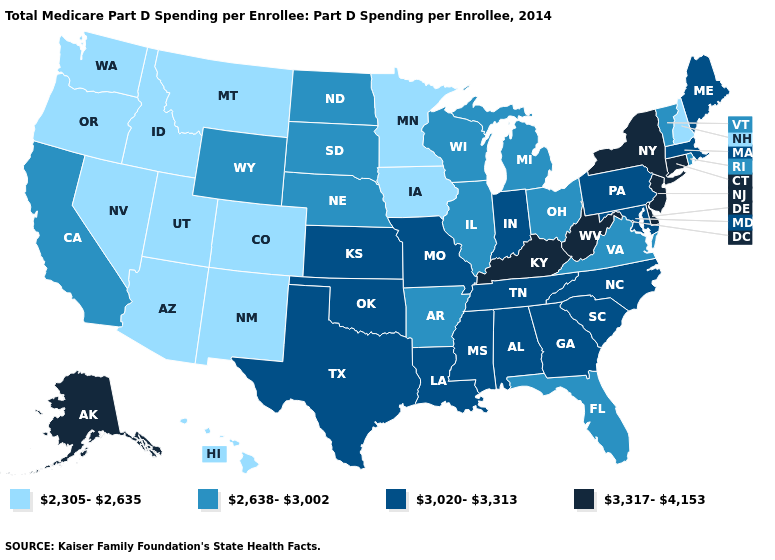What is the lowest value in the South?
Be succinct. 2,638-3,002. Name the states that have a value in the range 3,317-4,153?
Be succinct. Alaska, Connecticut, Delaware, Kentucky, New Jersey, New York, West Virginia. Does Utah have the lowest value in the West?
Give a very brief answer. Yes. Name the states that have a value in the range 2,305-2,635?
Quick response, please. Arizona, Colorado, Hawaii, Idaho, Iowa, Minnesota, Montana, Nevada, New Hampshire, New Mexico, Oregon, Utah, Washington. What is the highest value in the USA?
Short answer required. 3,317-4,153. Name the states that have a value in the range 3,317-4,153?
Be succinct. Alaska, Connecticut, Delaware, Kentucky, New Jersey, New York, West Virginia. What is the value of West Virginia?
Short answer required. 3,317-4,153. Among the states that border Nebraska , which have the highest value?
Answer briefly. Kansas, Missouri. Name the states that have a value in the range 3,020-3,313?
Be succinct. Alabama, Georgia, Indiana, Kansas, Louisiana, Maine, Maryland, Massachusetts, Mississippi, Missouri, North Carolina, Oklahoma, Pennsylvania, South Carolina, Tennessee, Texas. Is the legend a continuous bar?
Concise answer only. No. Name the states that have a value in the range 2,305-2,635?
Give a very brief answer. Arizona, Colorado, Hawaii, Idaho, Iowa, Minnesota, Montana, Nevada, New Hampshire, New Mexico, Oregon, Utah, Washington. What is the lowest value in states that border Iowa?
Be succinct. 2,305-2,635. What is the highest value in states that border Michigan?
Give a very brief answer. 3,020-3,313. What is the value of Vermont?
Short answer required. 2,638-3,002. Name the states that have a value in the range 2,638-3,002?
Give a very brief answer. Arkansas, California, Florida, Illinois, Michigan, Nebraska, North Dakota, Ohio, Rhode Island, South Dakota, Vermont, Virginia, Wisconsin, Wyoming. 